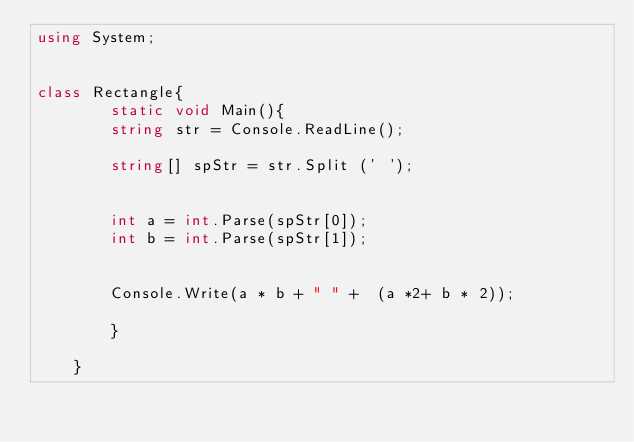<code> <loc_0><loc_0><loc_500><loc_500><_C#_>using System;


class Rectangle{
		static void Main(){
		string str = Console.ReadLine();

		string[] spStr = str.Split (' ');


		int a = int.Parse(spStr[0]);
		int b = int.Parse(spStr[1]);


		Console.Write(a * b + " " +  (a *2+ b * 2));

		}

	}</code> 